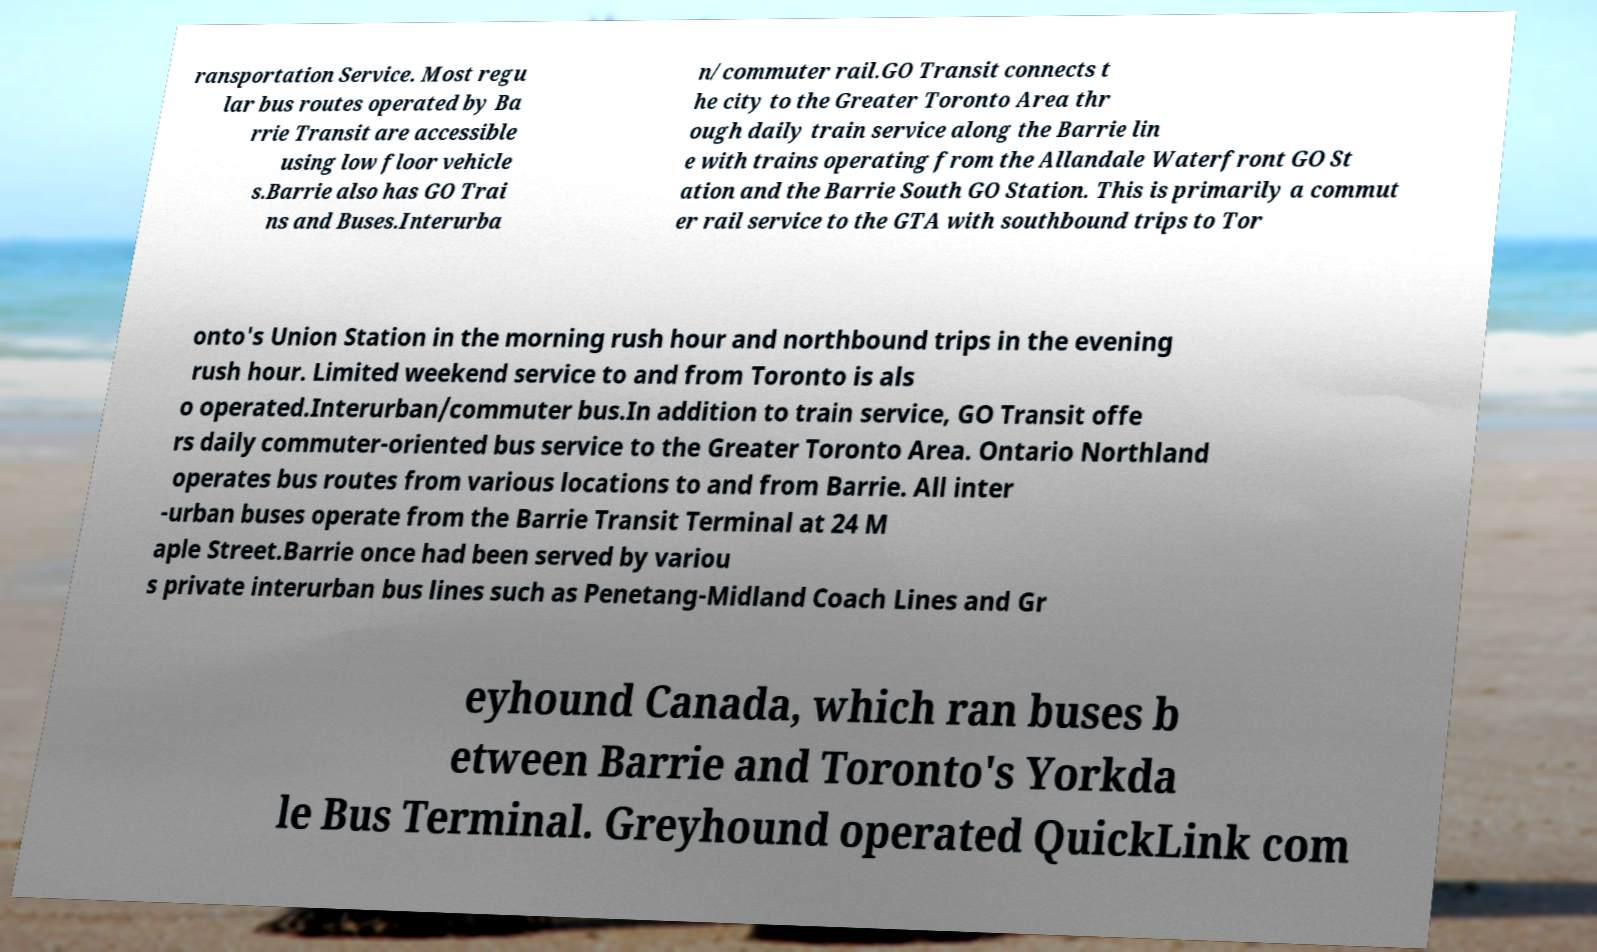Could you assist in decoding the text presented in this image and type it out clearly? ransportation Service. Most regu lar bus routes operated by Ba rrie Transit are accessible using low floor vehicle s.Barrie also has GO Trai ns and Buses.Interurba n/commuter rail.GO Transit connects t he city to the Greater Toronto Area thr ough daily train service along the Barrie lin e with trains operating from the Allandale Waterfront GO St ation and the Barrie South GO Station. This is primarily a commut er rail service to the GTA with southbound trips to Tor onto's Union Station in the morning rush hour and northbound trips in the evening rush hour. Limited weekend service to and from Toronto is als o operated.Interurban/commuter bus.In addition to train service, GO Transit offe rs daily commuter-oriented bus service to the Greater Toronto Area. Ontario Northland operates bus routes from various locations to and from Barrie. All inter -urban buses operate from the Barrie Transit Terminal at 24 M aple Street.Barrie once had been served by variou s private interurban bus lines such as Penetang-Midland Coach Lines and Gr eyhound Canada, which ran buses b etween Barrie and Toronto's Yorkda le Bus Terminal. Greyhound operated QuickLink com 